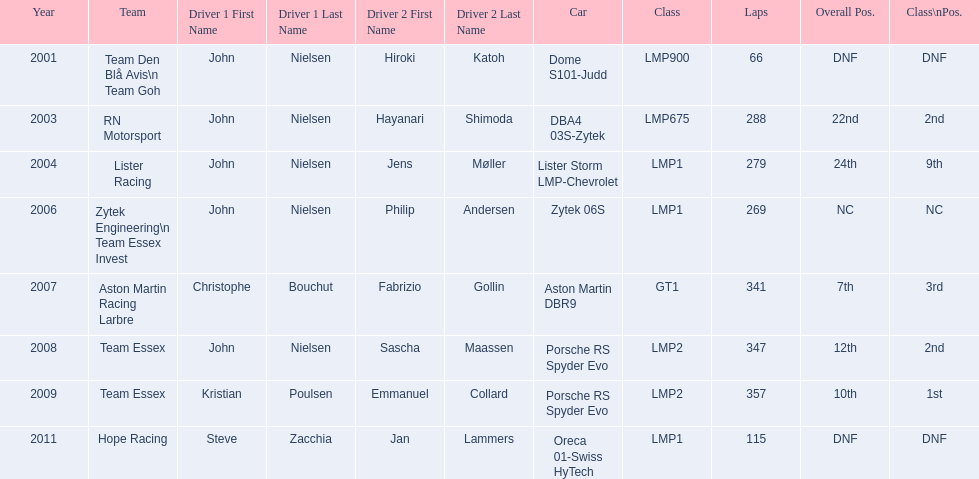Who was john nielsen co-driver for team lister in 2004? Jens Møller. 